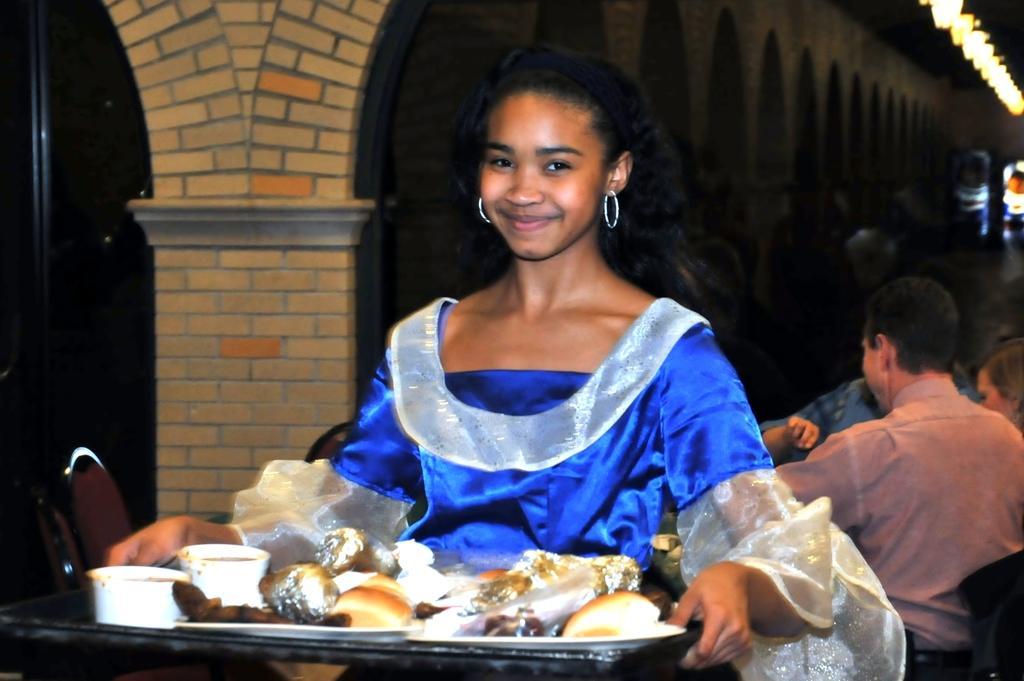In one or two sentences, can you explain what this image depicts? In this picture we can see a girl,she is smiling,she is holding a tray,on this tray we can see food items and in the background we can see people. 